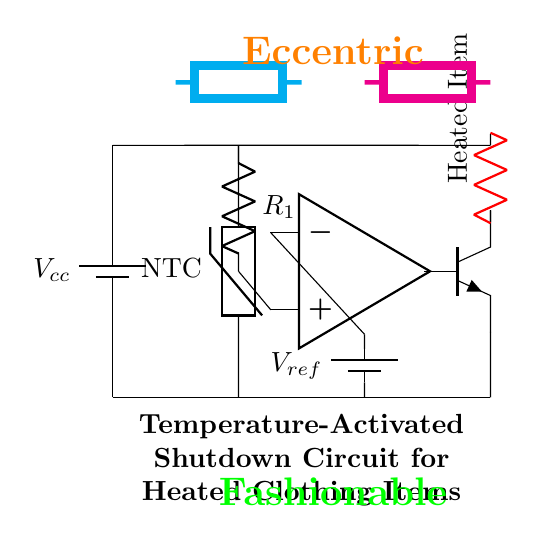What type of sensor is used in the circuit? The circuit uses a thermistor, specifically an NTC (negative temperature coefficient) thermistor, indicated by the label.
Answer: NTC thermistor What component is responsible for comparing voltages? The op-amp in the circuit functions as a comparator, comparing the voltage from the resistor divider to a reference voltage.
Answer: Op-amp What happens when the temperature exceeds the set limit? If the temperature exceeds the predetermined limit, the op-amp activates the transistor, which disconnects the heated clothing item from the power supply.
Answer: Shutdown What is the function of the resistor labeled R1? Resistor R1 forms part of the voltage divider that allows the circuit to sense the voltage changes corresponding to temperature variations.
Answer: Voltage divider How is power supplied to the heated clothing item? The heated clothing item receives power through the transistor, which is controlled by the op-amp based on temperature readings.
Answer: Through a transistor What type of protection does this circuit provide? The circuit provides thermal protection by shutting down the heated clothing item to prevent overheating.
Answer: Thermal protection 